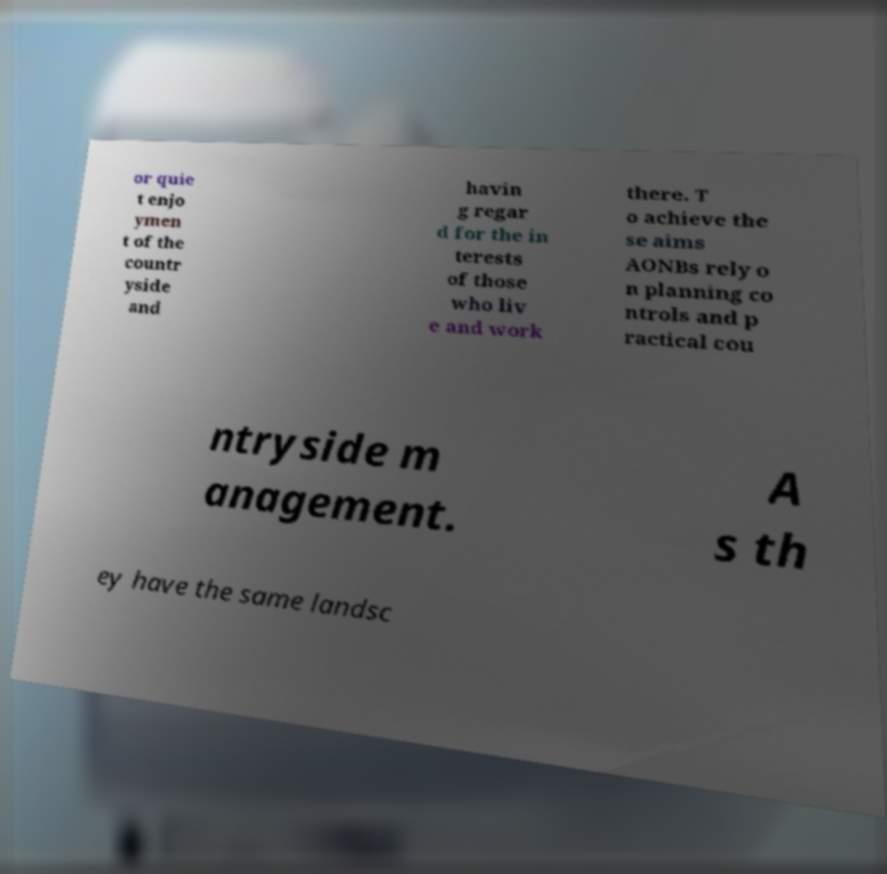Please identify and transcribe the text found in this image. or quie t enjo ymen t of the countr yside and havin g regar d for the in terests of those who liv e and work there. T o achieve the se aims AONBs rely o n planning co ntrols and p ractical cou ntryside m anagement. A s th ey have the same landsc 